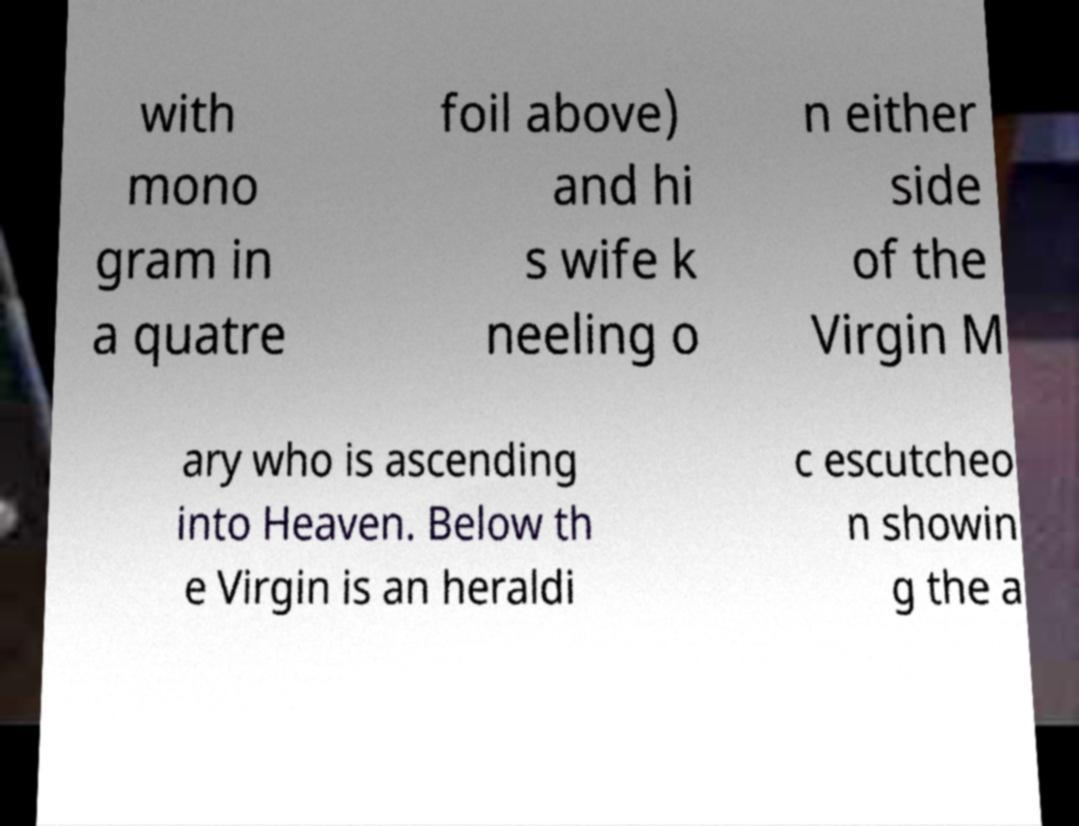Could you extract and type out the text from this image? with mono gram in a quatre foil above) and hi s wife k neeling o n either side of the Virgin M ary who is ascending into Heaven. Below th e Virgin is an heraldi c escutcheo n showin g the a 